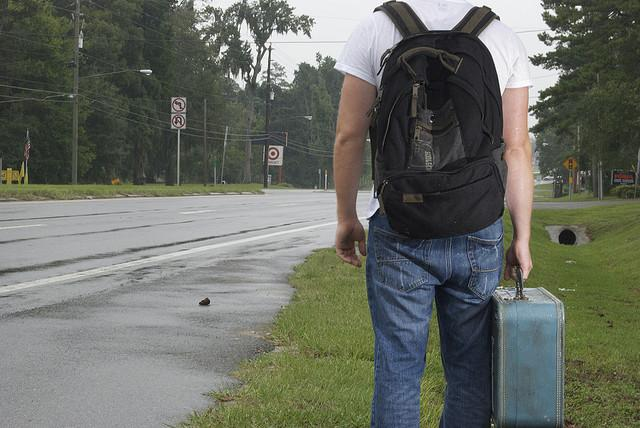What sign is on right side of the road? traffic light 